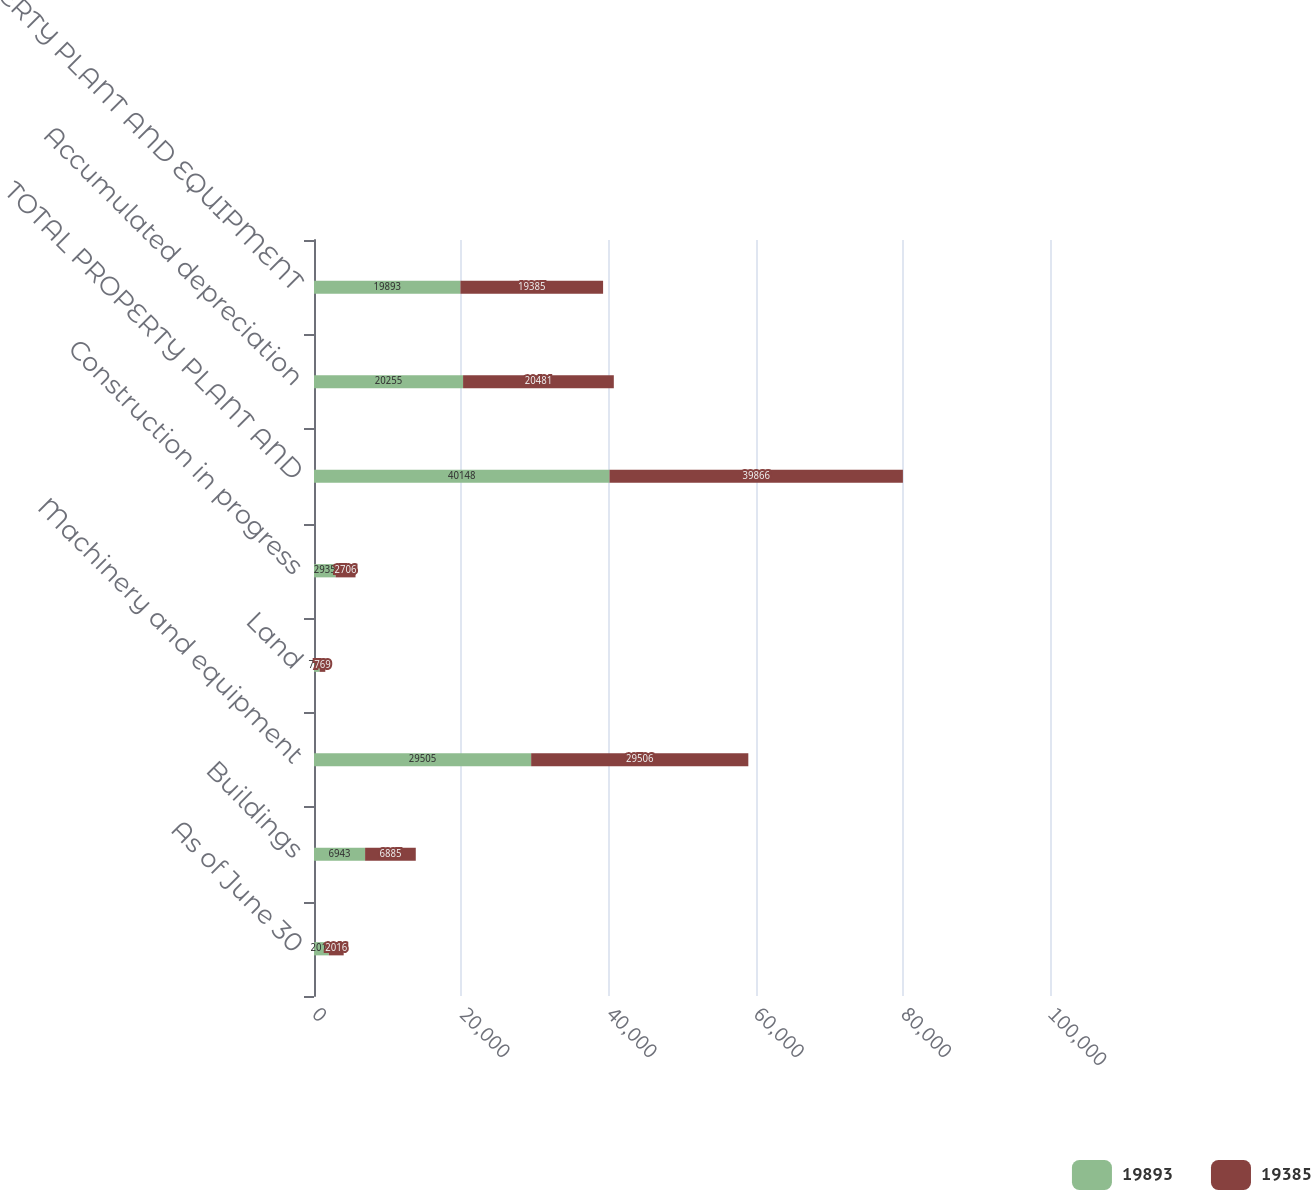Convert chart. <chart><loc_0><loc_0><loc_500><loc_500><stacked_bar_chart><ecel><fcel>As of June 30<fcel>Buildings<fcel>Machinery and equipment<fcel>Land<fcel>Construction in progress<fcel>TOTAL PROPERTY PLANT AND<fcel>Accumulated depreciation<fcel>PROPERTY PLANT AND EQUIPMENT<nl><fcel>19893<fcel>2017<fcel>6943<fcel>29505<fcel>765<fcel>2935<fcel>40148<fcel>20255<fcel>19893<nl><fcel>19385<fcel>2016<fcel>6885<fcel>29506<fcel>769<fcel>2706<fcel>39866<fcel>20481<fcel>19385<nl></chart> 